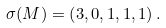<formula> <loc_0><loc_0><loc_500><loc_500>\sigma ( M ) = \left ( 3 , 0 , 1 , 1 , 1 \right ) .</formula> 